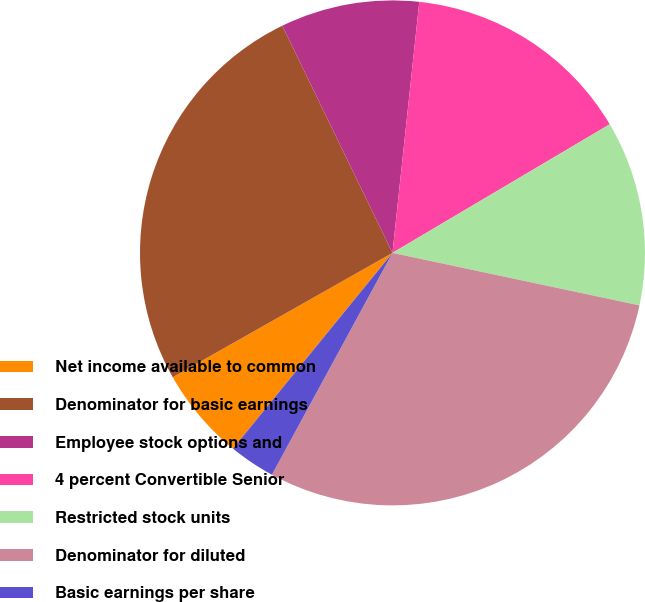Convert chart to OTSL. <chart><loc_0><loc_0><loc_500><loc_500><pie_chart><fcel>Net income available to common<fcel>Denominator for basic earnings<fcel>Employee stock options and<fcel>4 percent Convertible Senior<fcel>Restricted stock units<fcel>Denominator for diluted<fcel>Basic earnings per share<fcel>Diluted earnings per share<nl><fcel>5.92%<fcel>26.01%<fcel>8.88%<fcel>14.8%<fcel>11.84%<fcel>29.59%<fcel>2.96%<fcel>0.0%<nl></chart> 